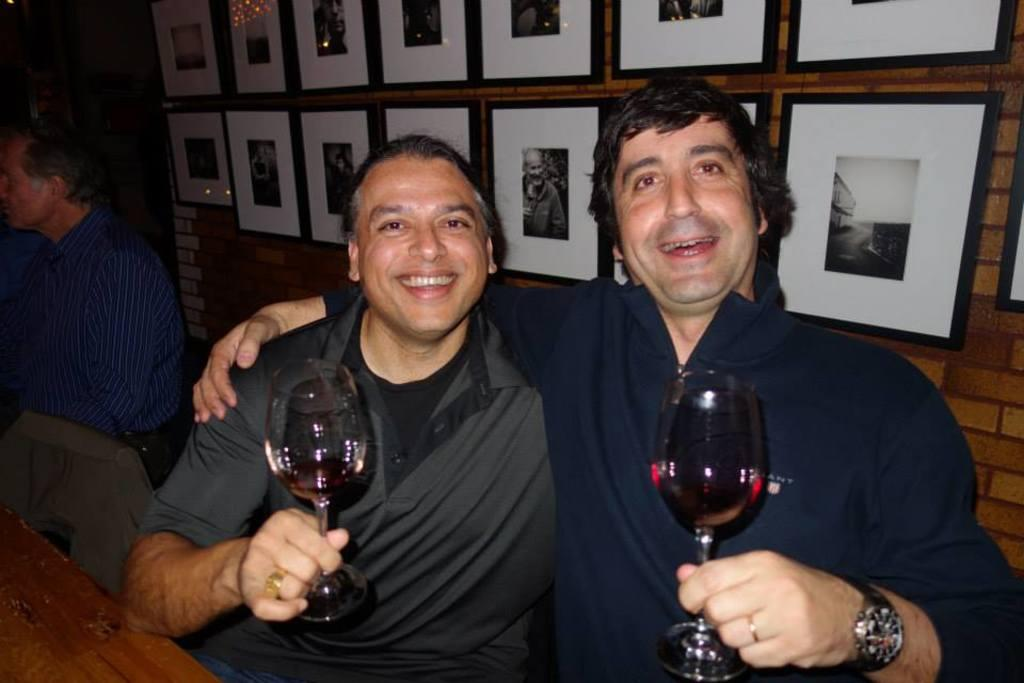How many people are in the image? There are three persons in the image. What are the persons doing in the image? The three persons are sitting. What is the facial expression of the persons in the image? Two of the persons are smiling. What are the two smiling persons holding in their hands? The two smiling persons are holding glasses in their hands. What can be seen in the background of the image? There is a wall in the background of the image. What is on the wall in the background? There are multiple photo frames on the wall. What type of gold jewelry is the writer wearing in the image? There is no writer or gold jewelry present in the image. 